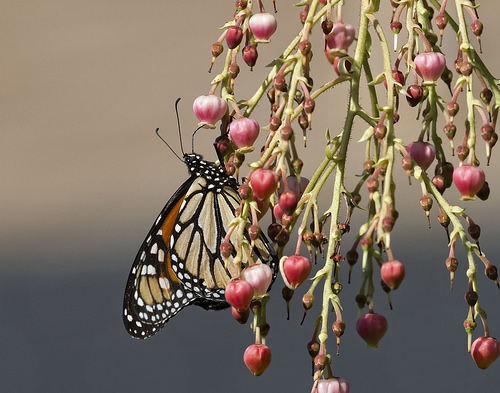<image>
Is there a butterfly on the branch? Yes. Looking at the image, I can see the butterfly is positioned on top of the branch, with the branch providing support. Where is the fruit in relation to the fly? Is it on the fly? No. The fruit is not positioned on the fly. They may be near each other, but the fruit is not supported by or resting on top of the fly. 